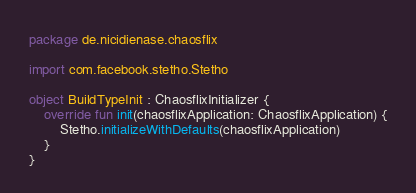<code> <loc_0><loc_0><loc_500><loc_500><_Kotlin_>package de.nicidienase.chaosflix

import com.facebook.stetho.Stetho

object BuildTypeInit : ChaosflixInitializer {
    override fun init(chaosflixApplication: ChaosflixApplication) {
        Stetho.initializeWithDefaults(chaosflixApplication)
    }
}
</code> 